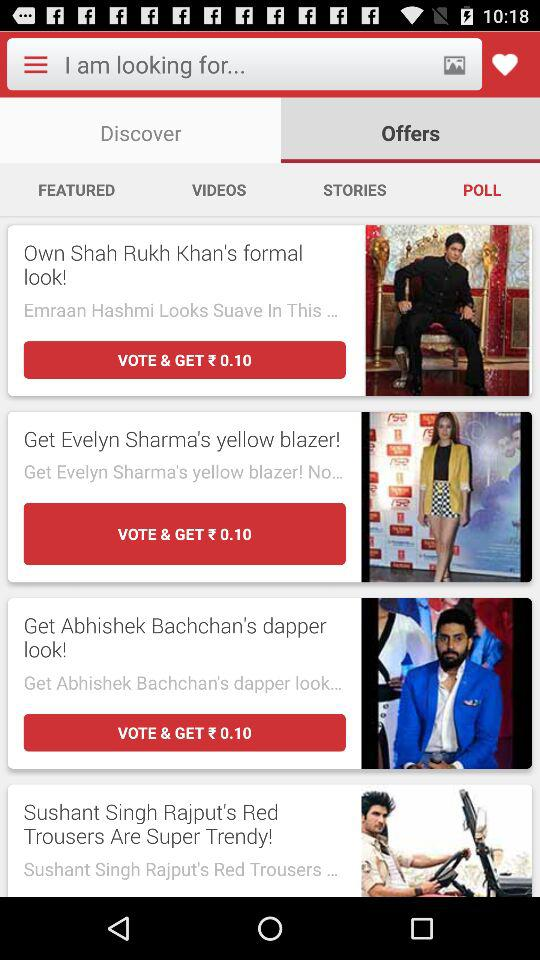How much does "Evelyn Sharma's yellow blazer!" cost in USD?
When the provided information is insufficient, respond with <no answer>. <no answer> 